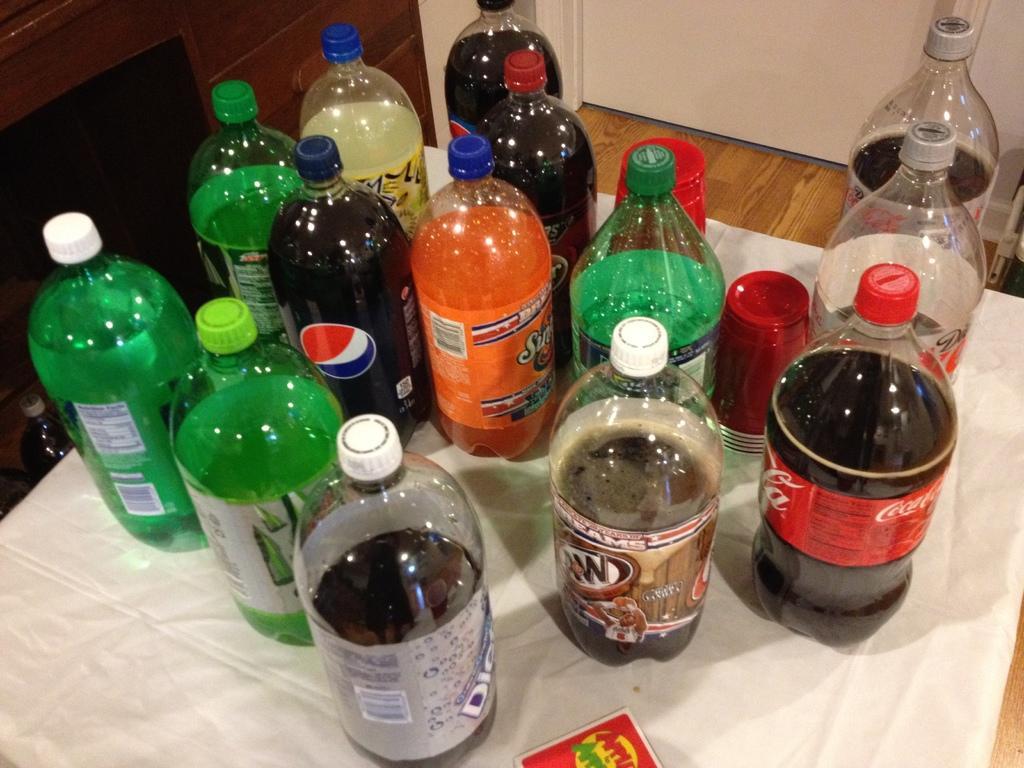In one or two sentences, can you explain what this image depicts? In this image, there are few bottles are placed on the wooden table. Here there is a match box at the bottom. On right side, we can see a white color wall. On left side, we can see wooden cupboards. Here the few glasses are there. 